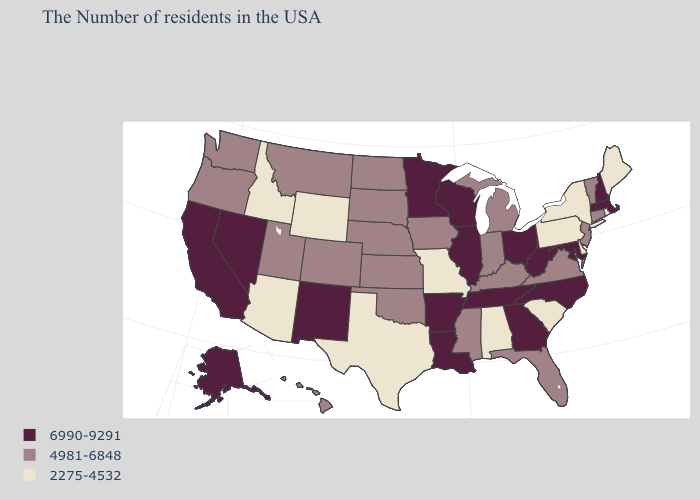What is the highest value in the West ?
Short answer required. 6990-9291. Does the first symbol in the legend represent the smallest category?
Write a very short answer. No. Among the states that border Alabama , does Georgia have the lowest value?
Be succinct. No. Does Alaska have the highest value in the USA?
Concise answer only. Yes. Which states have the lowest value in the West?
Short answer required. Wyoming, Arizona, Idaho. What is the highest value in the USA?
Be succinct. 6990-9291. Name the states that have a value in the range 6990-9291?
Concise answer only. Massachusetts, New Hampshire, Maryland, North Carolina, West Virginia, Ohio, Georgia, Tennessee, Wisconsin, Illinois, Louisiana, Arkansas, Minnesota, New Mexico, Nevada, California, Alaska. Name the states that have a value in the range 2275-4532?
Write a very short answer. Maine, Rhode Island, New York, Delaware, Pennsylvania, South Carolina, Alabama, Missouri, Texas, Wyoming, Arizona, Idaho. Does Massachusetts have the lowest value in the USA?
Short answer required. No. What is the value of Michigan?
Answer briefly. 4981-6848. What is the highest value in states that border Kentucky?
Keep it brief. 6990-9291. Name the states that have a value in the range 2275-4532?
Be succinct. Maine, Rhode Island, New York, Delaware, Pennsylvania, South Carolina, Alabama, Missouri, Texas, Wyoming, Arizona, Idaho. What is the lowest value in the USA?
Give a very brief answer. 2275-4532. What is the value of Nevada?
Give a very brief answer. 6990-9291. 